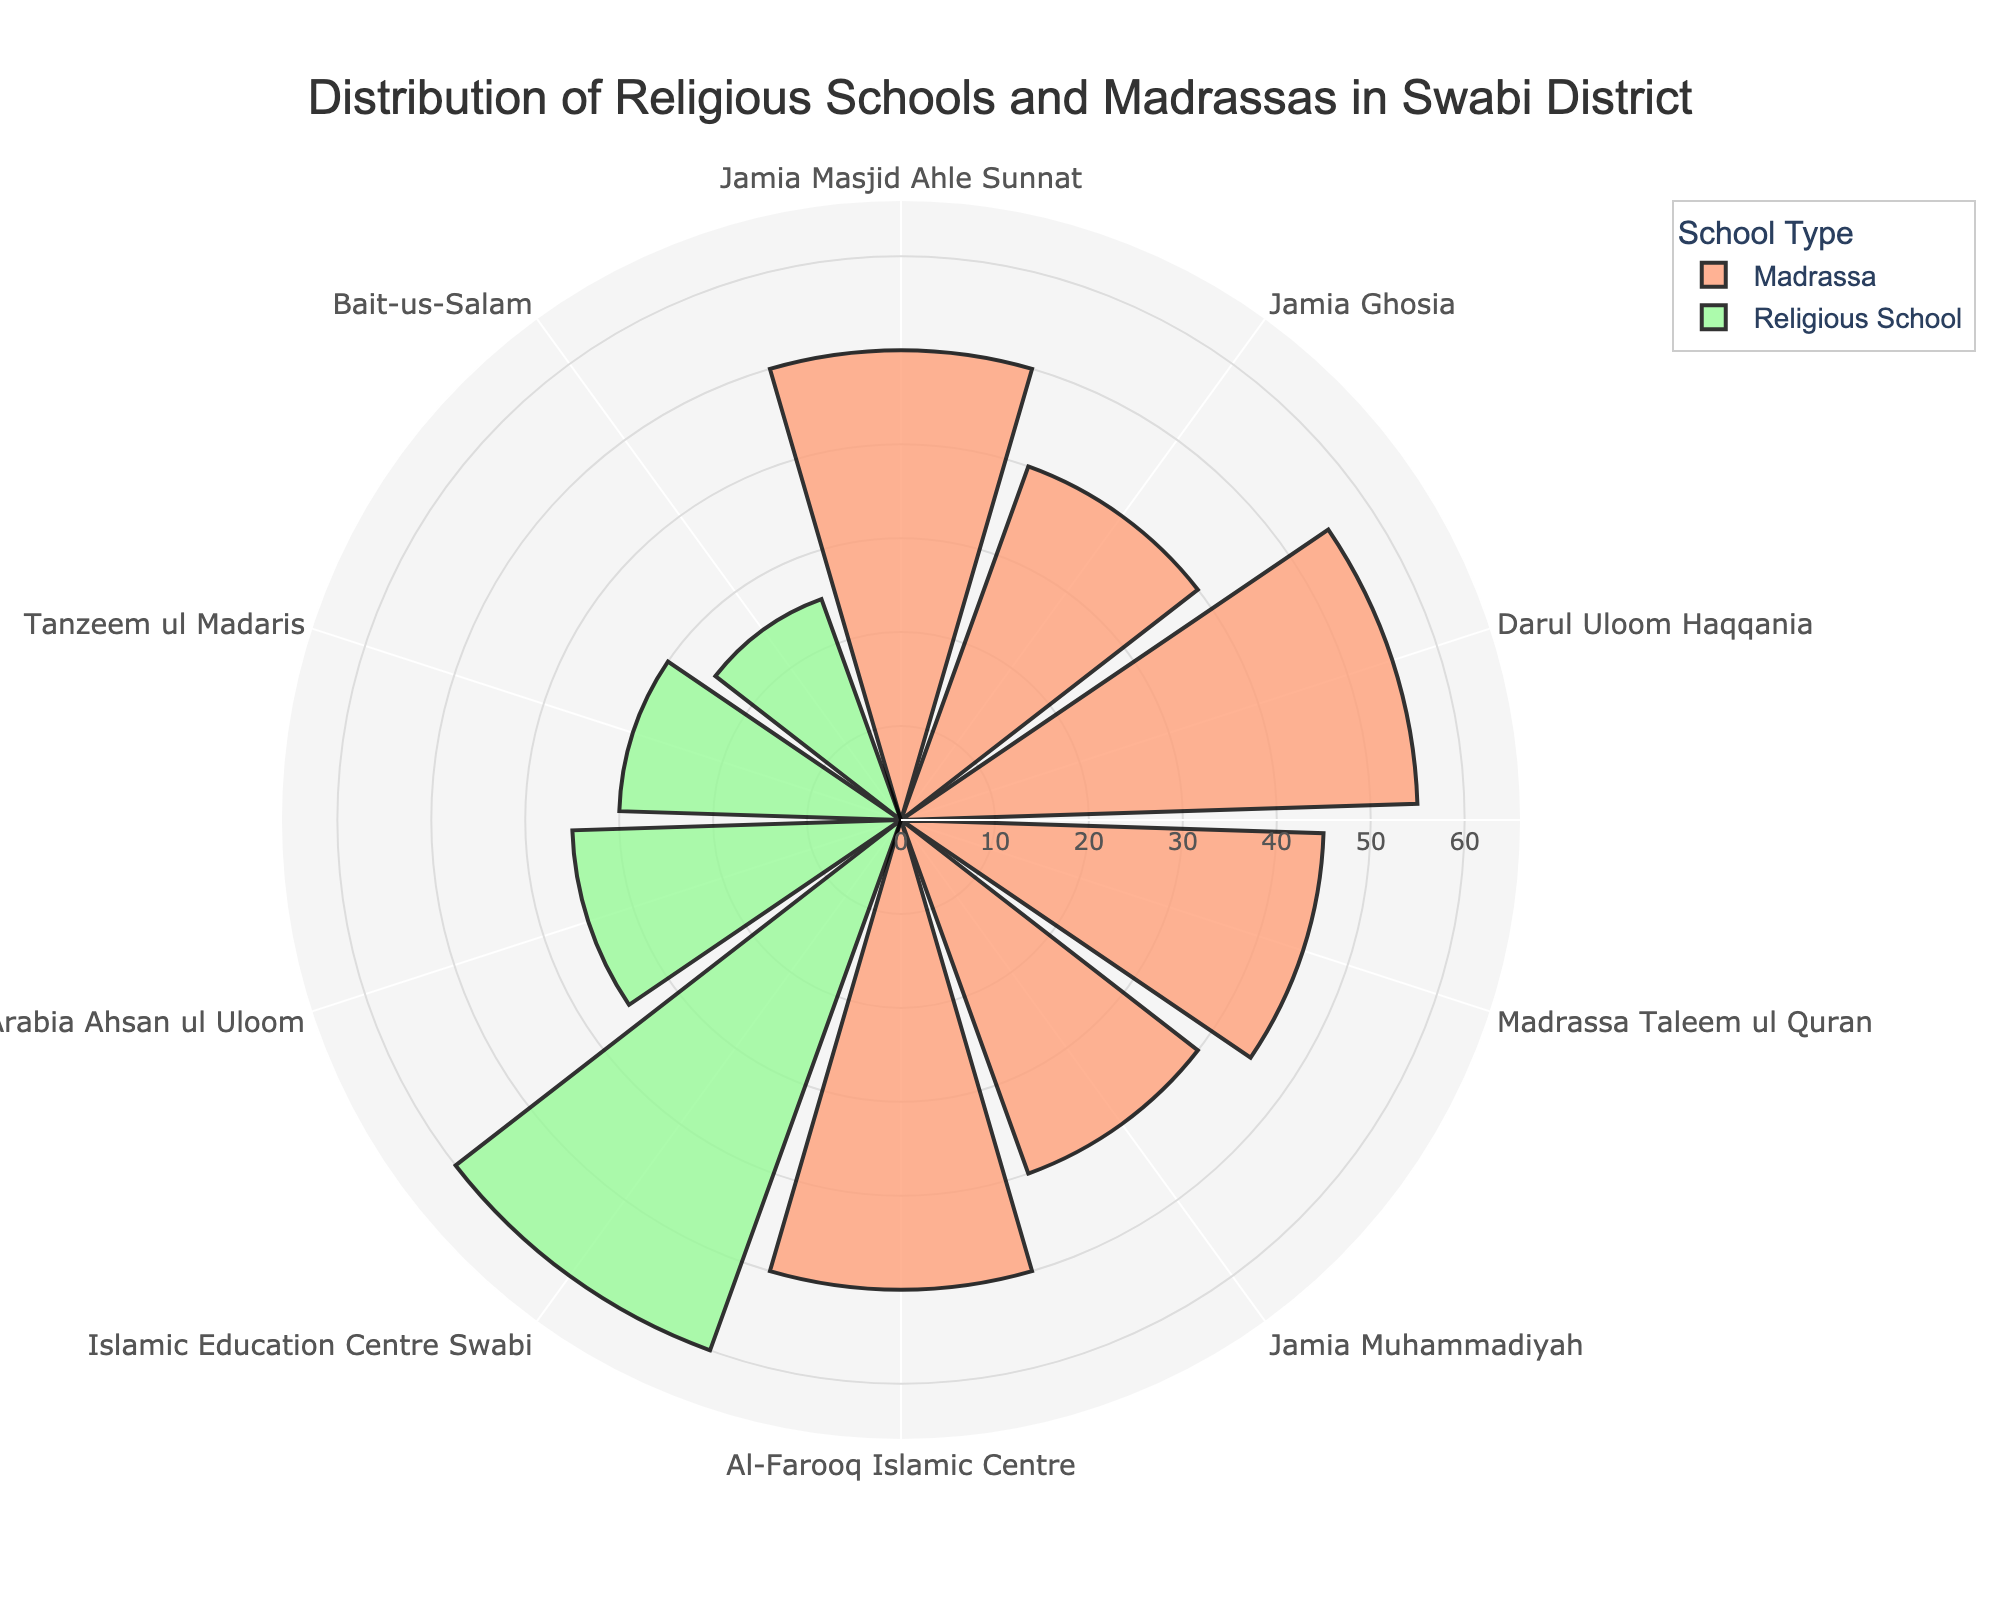What is the title of the plot? The title of the plot is mentioned at the top.
Answer: Distribution of Religious Schools and Madrassas in Swabi District How many schools are under the category 'Religious School'? By looking at the chart, count the number of bars colored for 'Religious School'.
Answer: 4 Which Madrassa has the highest count? Identify the Madrassa with the longest bar on the rose chart for Madrassas.
Answer: Darul Uloom Haqqania What is the combined count of Jamia Masjid Ahle Sunnat and Al-Farooq Islamic Centre? Add the counts of both Madrassas: 50 (Jamia Masjid Ahle Sunnat) + 50 (Al-Farooq Islamic Centre) = 100.
Answer: 100 Which type of institution has a higher total count, Madrassas or Religious Schools? Look at the aggregated bar lengths or legend to determine which type has a higher combined count.
Answer: Madrassas What is the count difference between the highest and lowest counted Religious School? Subtract the count of the smallest bar from the largest bar within Religious Schools: 60 (Islamic Education Centre Swabi) - 25 (Bait-us-Salam) = 35
Answer: 35 How many different school names are represented in the plot? Count all unique school names listed in the chart.
Answer: 10 Which Religious School has the smallest count? Identify the shortest bar within the category of Religious Schools.
Answer: Bait-us-Salam If you combine the counts of all the Madrassas, what is the total? Sum the counts of all Madrassas: 50 (Jamia Masjid Ahle Sunnat) + 40 (Jamia Ghosia) + 55 (Darul Uloom Haqqania) + 45 (Madrassa Taleem ul Quran) + 40 (Jamia Muhammadiyah) + 50 (Al-Farooq Islamic Centre) = 280
Answer: 280 What is the average count of all the Religious Schools? Calculate the average by summing the counts and dividing by the number of Religious Schools: (60 + 35 + 30 + 25) / 4 = 37.5
Answer: 37.5 